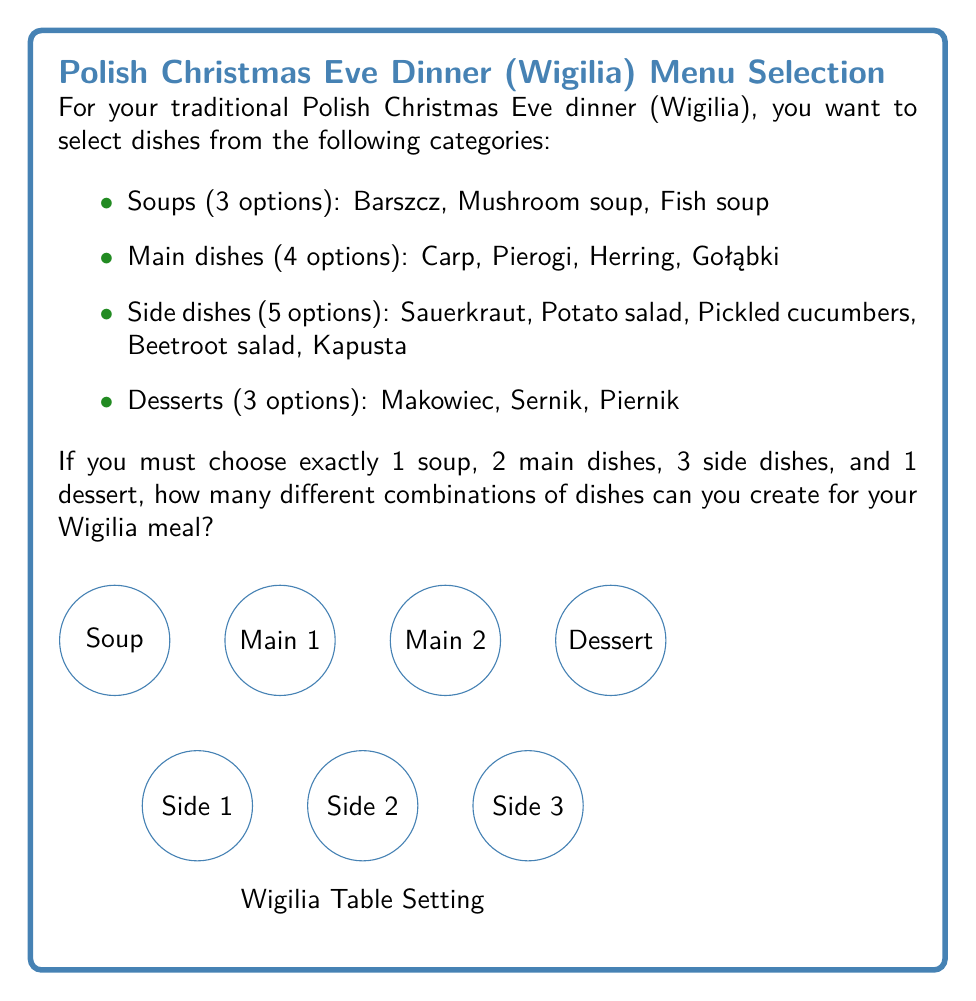What is the answer to this math problem? Let's approach this step-by-step using the multiplication principle of combinatorics:

1) For the soup, we have 3 choices, and we must choose 1. This can be done in $\binom{3}{1} = 3$ ways.

2) For main dishes, we need to choose 2 out of 4 options. This can be done in $\binom{4}{2} = 6$ ways.

3) For side dishes, we need to choose 3 out of 5 options. This can be done in $\binom{5}{3} = 10$ ways.

4) For dessert, we have 3 choices, and we must choose 1. This can be done in $\binom{3}{1} = 3$ ways.

Now, according to the multiplication principle, if we have a sequence of choices where we have $m$ ways of making the first choice, $n$ ways of making the second choice, $p$ ways of making the third choice, and so on, then the total number of ways to make all these choices is $m \times n \times p \times \cdots$

Therefore, the total number of different combinations is:

$$3 \times 6 \times 10 \times 3 = 540$$

This means there are 540 different ways to create your Wigilia meal with the given constraints.
Answer: 540 combinations 